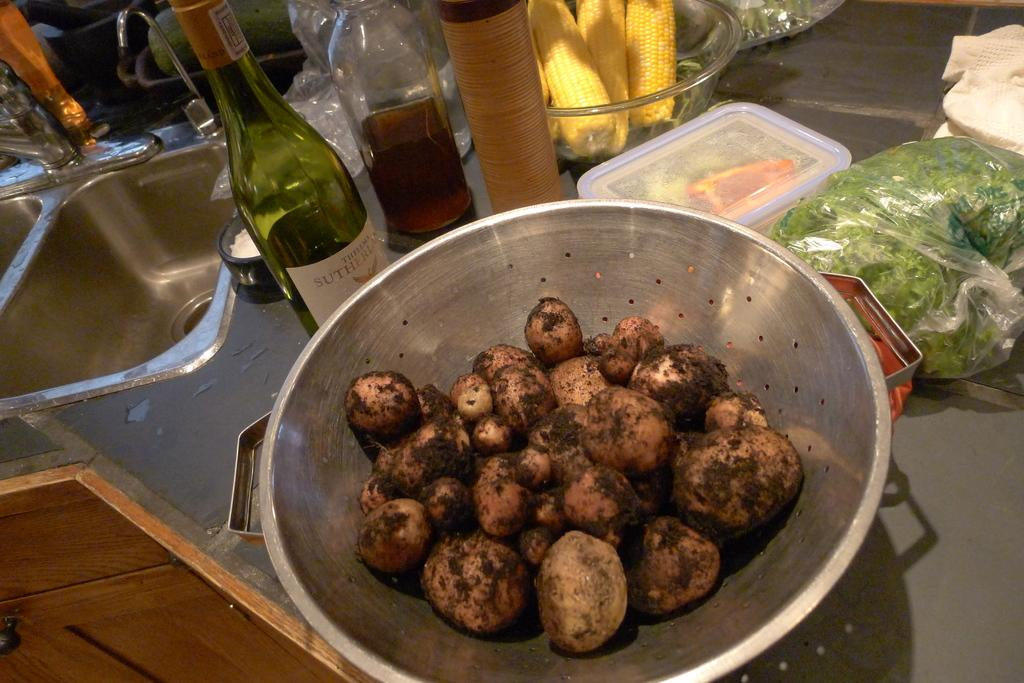What is in the bowl that is visible in the image? There is a bowl of food in the image. What beverage is present in the image? There is a bottle of wine in the image. What type of containers can be seen in the image? There are boxes in the image. What type of food is visible in the image? There is corn present in the image. What is a feature of the room or setting in the image? There is a sink in the image. How many feet are visible in the image? There are no feet visible in the image. What type of payment is being made in the image? There is no payment being made in the image. What season is depicted in the image? The provided facts do not indicate a specific season, so it cannot be determined from the image. 